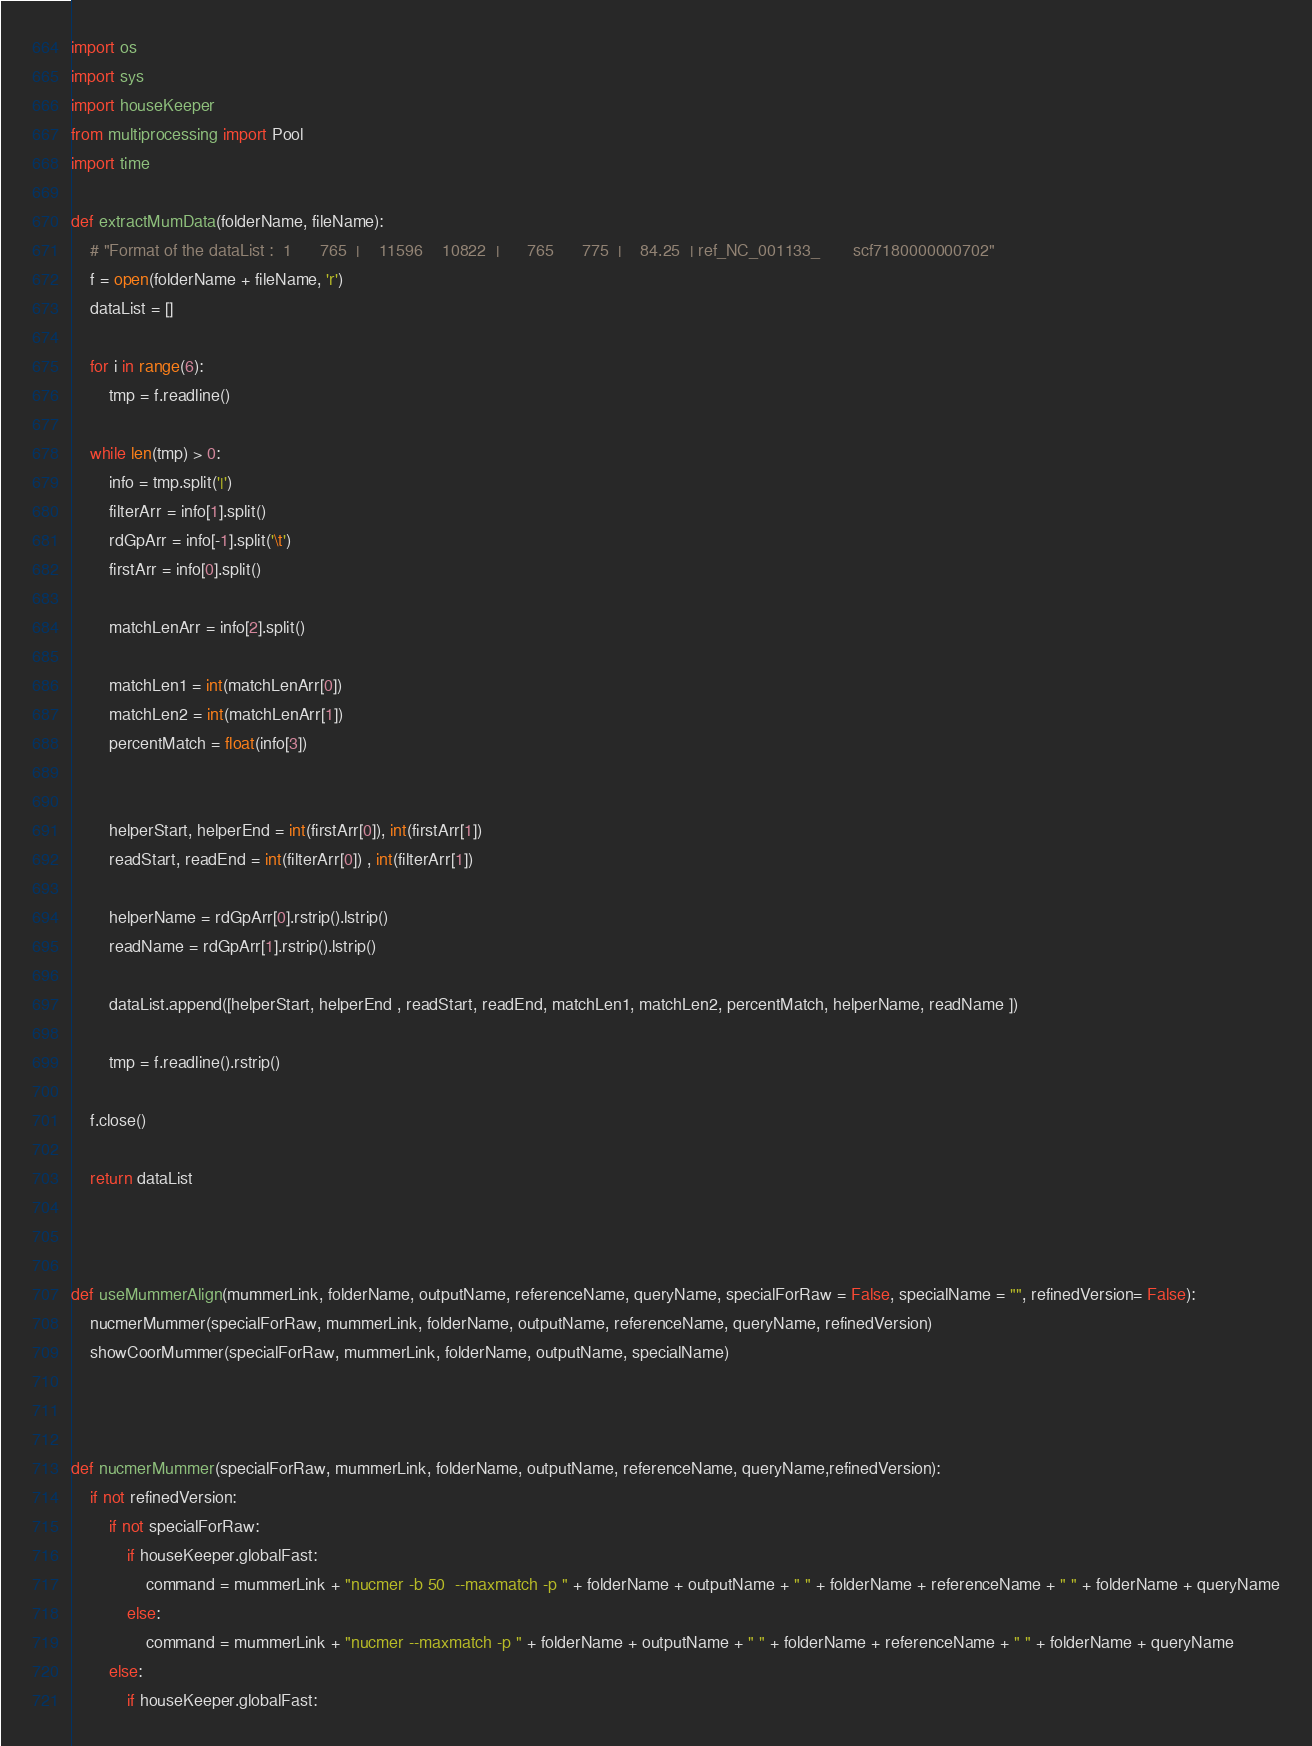Convert code to text. <code><loc_0><loc_0><loc_500><loc_500><_Python_>import os
import sys
import houseKeeper
from multiprocessing import Pool
import time

def extractMumData(folderName, fileName):
    # "Format of the dataList :  1      765  |    11596    10822  |      765      775  |    84.25  | ref_NC_001133_       scf7180000000702"
    f = open(folderName + fileName, 'r')
    dataList = []
    
    for i in range(6):
        tmp = f.readline()

    while len(tmp) > 0:
        info = tmp.split('|')
        filterArr = info[1].split()
        rdGpArr = info[-1].split('\t')
        firstArr = info[0].split()
        
        matchLenArr = info[2].split()
    
        matchLen1 = int(matchLenArr[0])
        matchLen2 = int(matchLenArr[1])    
        percentMatch = float(info[3])
        
        
        helperStart, helperEnd = int(firstArr[0]), int(firstArr[1])
        readStart, readEnd = int(filterArr[0]) , int(filterArr[1])
        
        helperName = rdGpArr[0].rstrip().lstrip()
        readName = rdGpArr[1].rstrip().lstrip()
        
        dataList.append([helperStart, helperEnd , readStart, readEnd, matchLen1, matchLen2, percentMatch, helperName, readName ])
    
        tmp = f.readline().rstrip()
                
    f.close()
    
    return dataList



def useMummerAlign(mummerLink, folderName, outputName, referenceName, queryName, specialForRaw = False, specialName = "", refinedVersion= False):
    nucmerMummer(specialForRaw, mummerLink, folderName, outputName, referenceName, queryName, refinedVersion)
    showCoorMummer(specialForRaw, mummerLink, folderName, outputName, specialName)
    
    

def nucmerMummer(specialForRaw, mummerLink, folderName, outputName, referenceName, queryName,refinedVersion):
    if not refinedVersion:
        if not specialForRaw:
            if houseKeeper.globalFast:
                command = mummerLink + "nucmer -b 50  --maxmatch -p " + folderName + outputName + " " + folderName + referenceName + " " + folderName + queryName
            else:
                command = mummerLink + "nucmer --maxmatch -p " + folderName + outputName + " " + folderName + referenceName + " " + folderName + queryName
        else:
            if houseKeeper.globalFast:</code> 